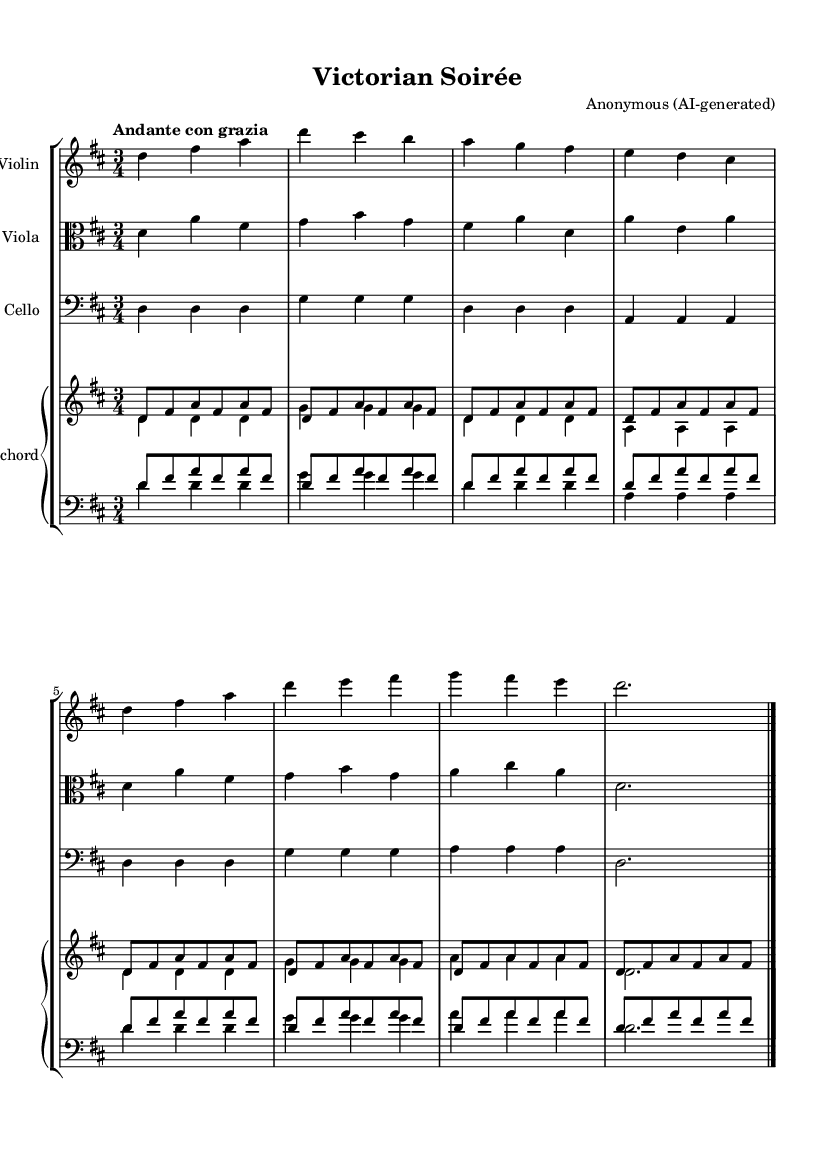What is the key signature of this music? The key signature is indicated by the number of sharps or flats beside the staff. In this sheet music, there are two sharps (F# and C#), which corresponds to the key of D major.
Answer: D major What is the time signature of this piece? The time signature is found at the beginning of the staff notation, shown as a fraction. Here, the presence of a "3/4" indicates that there are three beats in a measure and the quarter note gets the beat.
Answer: 3/4 What is the tempo marking for this piece? The tempo marking is written above the staff and typically indicates the speed and mood of the music. In this example, "Andante con grazia" suggests a moderate pace with gracefulness.
Answer: Andante con grazia How many instruments are featured in this composition? From the layout of the score, we can see four distinct staves for different instruments: violin, viola, cello, and harpsichord, which indicates a total of four instruments.
Answer: Four How does the harpsichord part compare to the violin part in this piece? By analyzing both parts, the harpsichord plays a repetitive arpeggiated pattern while the violin plays a more melodic line. The harpsichord often provides harmonization that complements the violin's melody.
Answer: Repetitive arpeggios vs. melodic line What is the overall mood suggested by the tempo and title of the piece? The title "Victorian Soirée" combined with the tempo marking "Andante con grazia" implies a social atmosphere typical of Victorian parlor entertainments, characterized by elegance and gracefulness, suitable for a gathering.
Answer: Elegant and graceful 